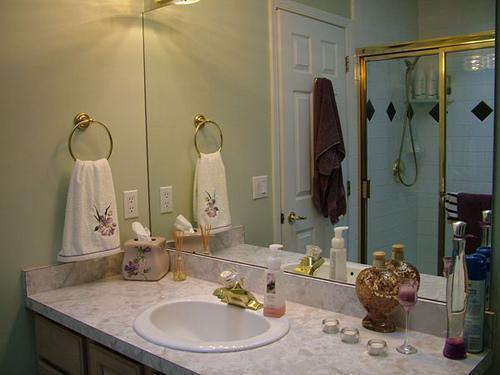What is closest to the place you would go to charge your phone?
Make your selection from the four choices given to correctly answer the question.
Options: White towel, tissues, candle, red towel. White towel. What color is the faucet above of the sink?
Pick the correct solution from the four options below to address the question.
Options: Blue, black, silver, yellow. Yellow. 